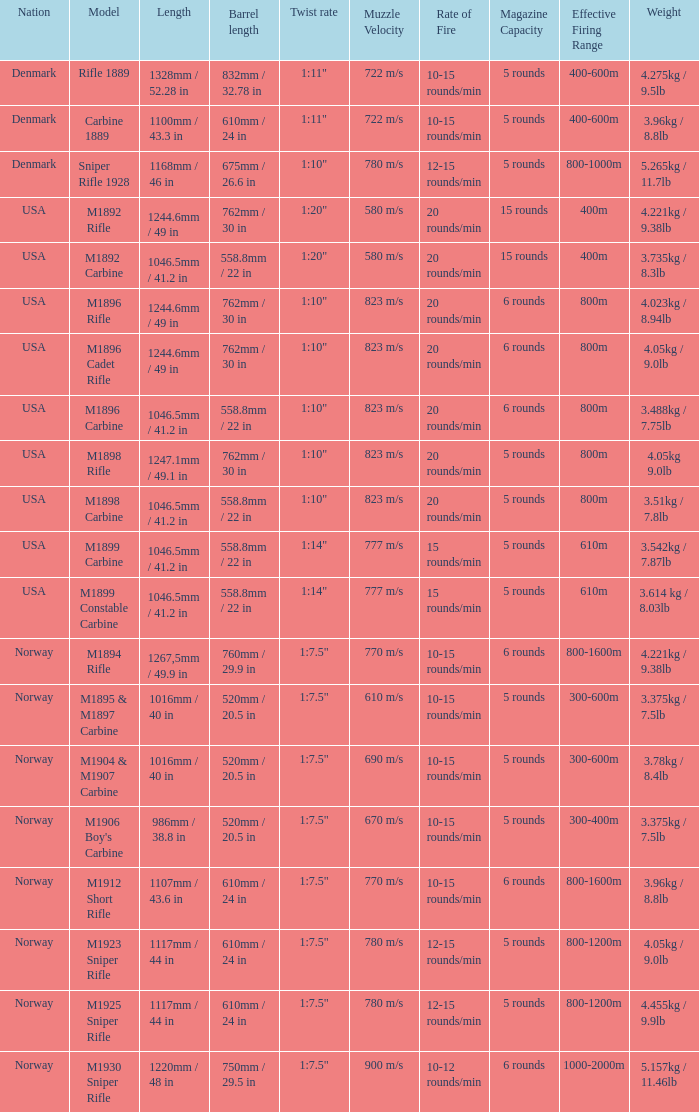What is Length, when Barrel Length is 750mm / 29.5 in? 1220mm / 48 in. 